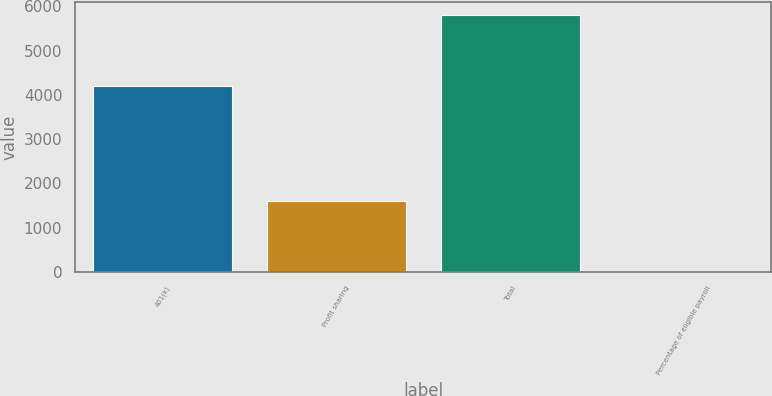Convert chart to OTSL. <chart><loc_0><loc_0><loc_500><loc_500><bar_chart><fcel>401(k)<fcel>Profit sharing<fcel>Total<fcel>Percentage of eligible payroll<nl><fcel>4203<fcel>1599<fcel>5802<fcel>1.8<nl></chart> 